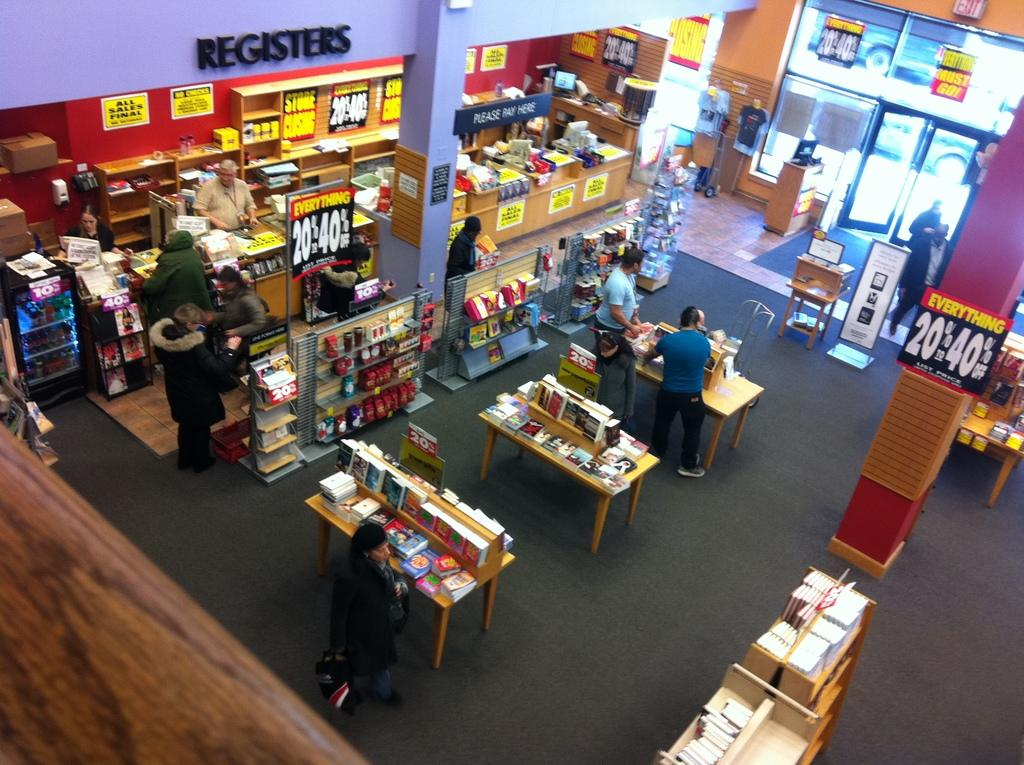<image>
Offer a succinct explanation of the picture presented. Yellow signs are displayed all over a book store advertising that everything is between 20 and 40 percent off. 